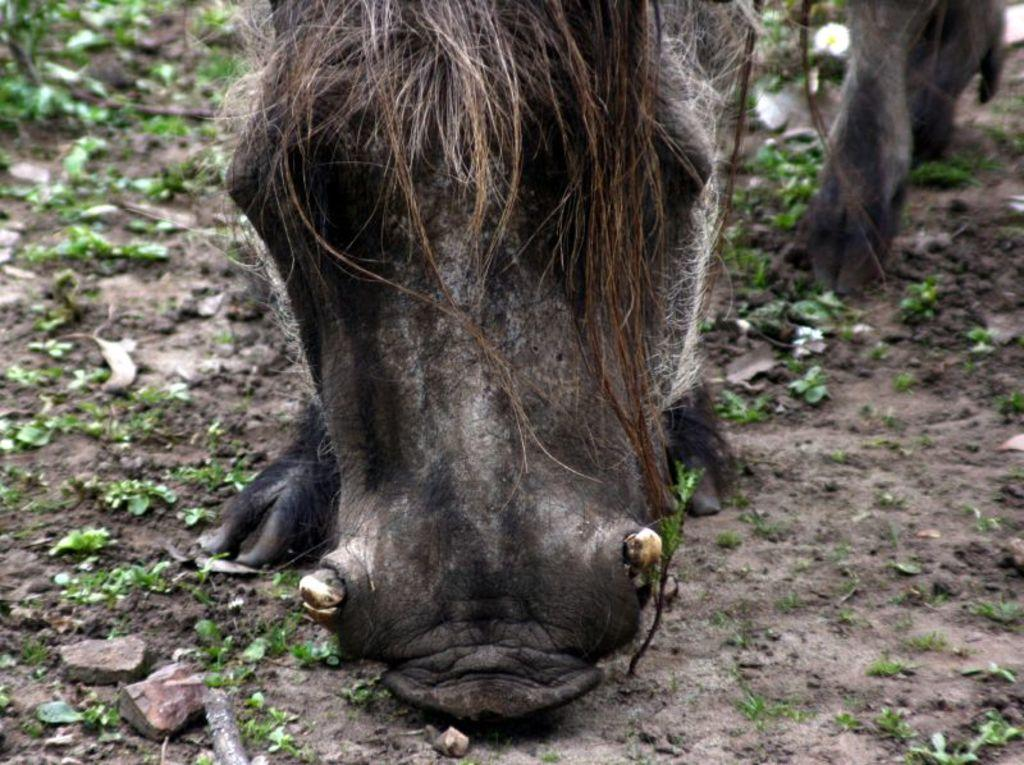What type of animal is present in the image? There is an animal in the image, but its specific type cannot be determined from the provided facts. What can be seen at the bottom of the image? There are stones at the bottom of the image. What type of vegetation is present in the image? There are plants on the ground in the image. What type of drain is visible in the image? There is no drain present in the image. How many roots can be seen growing from the plants in the image? The provided facts do not mention any roots, so we cannot determine the number of roots in the image. 